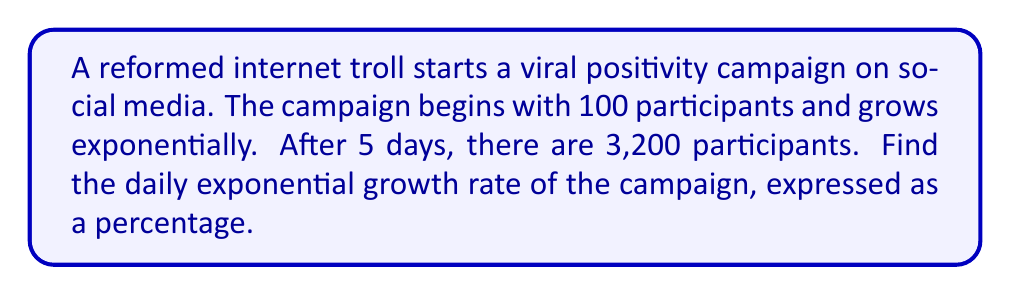Give your solution to this math problem. Let's approach this step-by-step:

1) The general formula for exponential growth is:
   $A = P(1 + r)^t$
   Where:
   $A$ = Final amount
   $P$ = Initial amount
   $r$ = Growth rate (in decimal form)
   $t$ = Time period

2) We know:
   $P = 100$ (initial participants)
   $A = 3200$ (participants after 5 days)
   $t = 5$ (days)

3) Let's plug these into our formula:
   $3200 = 100(1 + r)^5$

4) Divide both sides by 100:
   $32 = (1 + r)^5$

5) Take the 5th root of both sides:
   $\sqrt[5]{32} = 1 + r$

6) Simplify:
   $2 = 1 + r$

7) Subtract 1 from both sides:
   $r = 1$

8) Convert to a percentage:
   $r = 1 * 100\% = 100\%$

Therefore, the daily growth rate is 100%.
Answer: 100% 